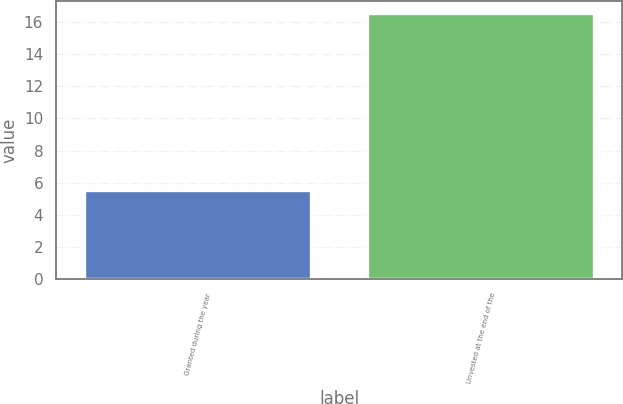Convert chart. <chart><loc_0><loc_0><loc_500><loc_500><bar_chart><fcel>Granted during the year<fcel>Unvested at the end of the<nl><fcel>5.5<fcel>16.5<nl></chart> 